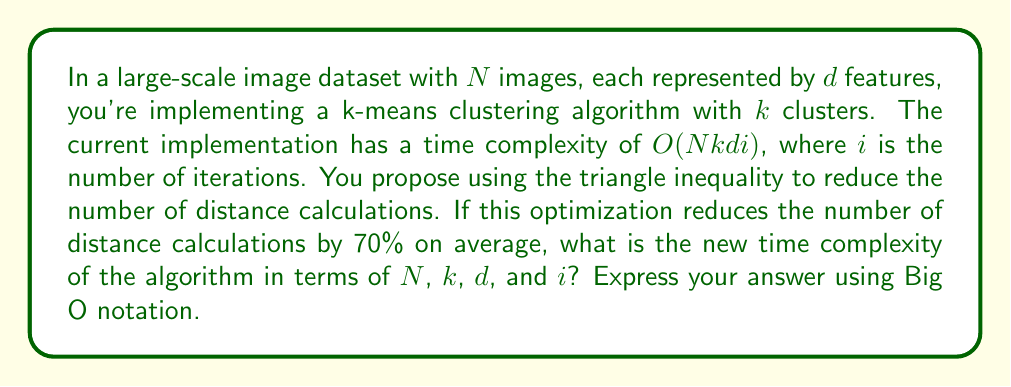Teach me how to tackle this problem. To optimize the runtime of the k-means clustering algorithm for large-scale image datasets, we can use the triangle inequality to reduce the number of distance calculations. Let's break down the problem and solve it step-by-step:

1. The original time complexity is $O(Nkdi)$, where:
   - $N$ is the number of images
   - $k$ is the number of clusters
   - $d$ is the number of features
   - $i$ is the number of iterations

2. The most computationally expensive part of k-means is calculating distances between points and cluster centroids, which occurs $Nk$ times per iteration.

3. The optimization using the triangle inequality reduces the number of distance calculations by 70% on average. This means we only perform 30% of the original distance calculations.

4. To reflect this optimization in the time complexity, we multiply the $Nk$ term by 0.3:

   $O(0.3 \cdot Nkdi)$

5. In Big O notation, we drop constant factors. Therefore, the 0.3 factor doesn't affect the overall complexity:

   $O(0.3 \cdot Nkdi) = O(Nkdi)$

6. This means that despite the significant reduction in the number of distance calculations, the asymptotic time complexity remains the same.

The reason for this is that Big O notation describes the upper bound of the growth rate of the function, and in this case, the growth rate with respect to $N$, $k$, $d$, and $i$ remains unchanged, even though the actual runtime will be significantly reduced.
Answer: $O(Nkdi)$ 